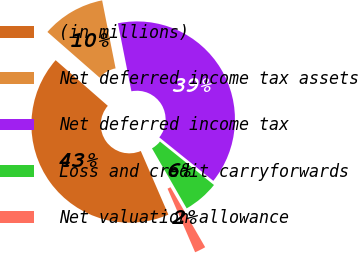<chart> <loc_0><loc_0><loc_500><loc_500><pie_chart><fcel>(in millions)<fcel>Net deferred income tax assets<fcel>Net deferred income tax<fcel>Loss and credit carryforwards<fcel>Net valuation allowance<nl><fcel>42.95%<fcel>10.45%<fcel>38.9%<fcel>5.87%<fcel>1.83%<nl></chart> 